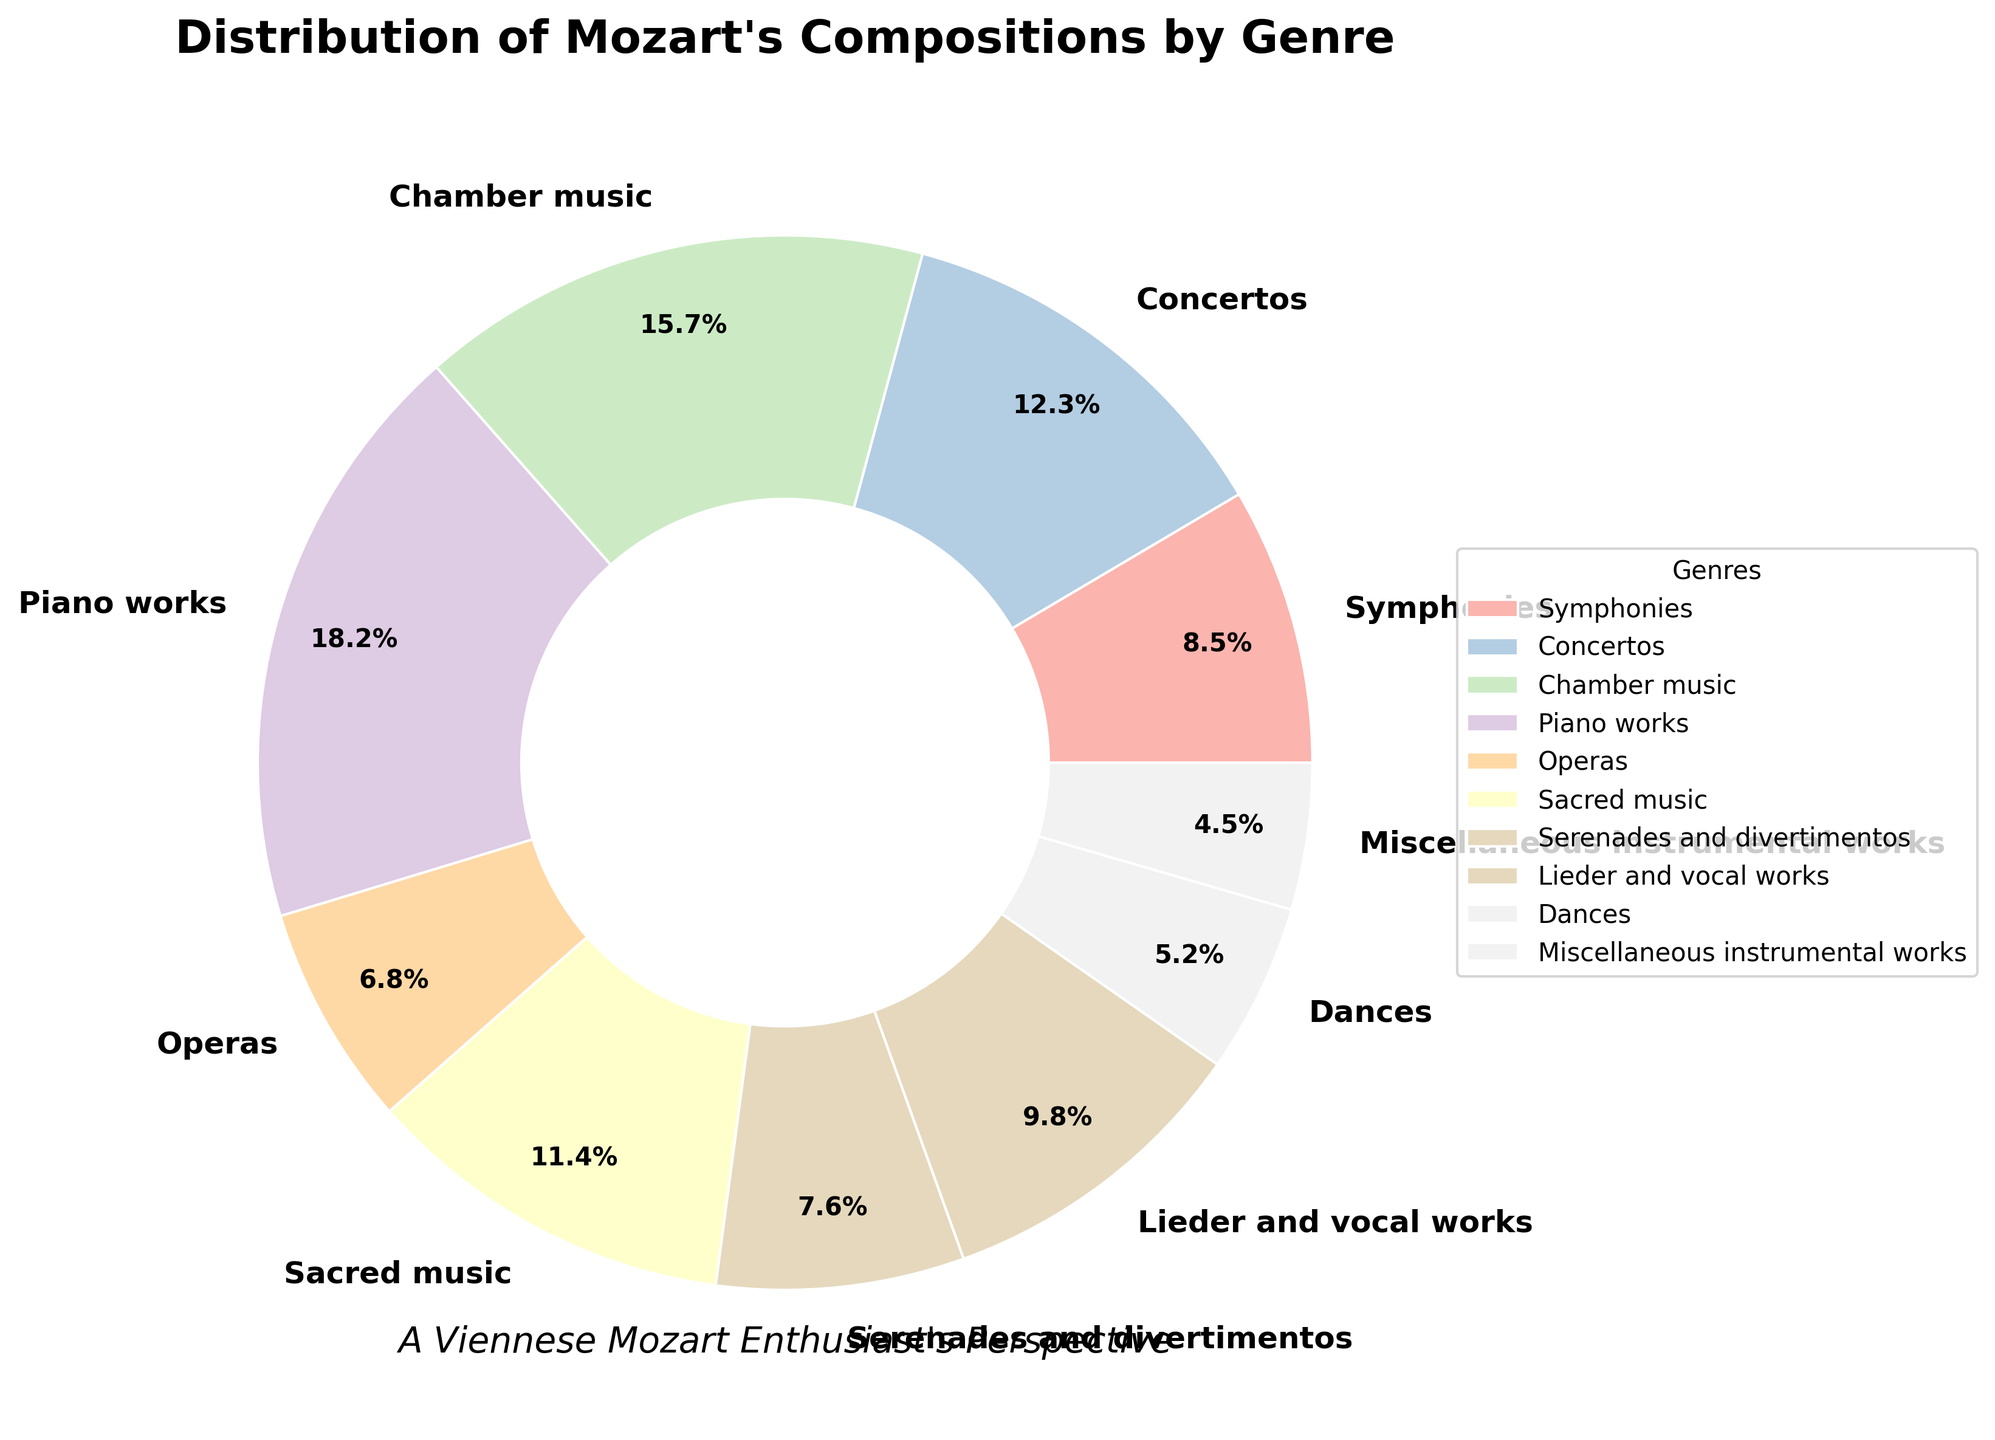what genre has the smallest percentage of Mozart's compositions? By looking at the pie chart, the segment labeled "Miscellaneous instrumental works" is the smallest.
Answer: Miscellaneous instrumental works Which genre has a higher percentage of Mozart's compositions: Operas or Lieder and vocal works? In the pie chart, the segment for Lieder and vocal works is labeled with 9.8% and the segment for Operas is labeled with 6.8%. Therefore, Lieder and vocal works have a higher percentage than Operas.
Answer: Lieder and vocal works What is the total percentage of Mozart's compositions in Piano works and Chamber music? From the pie chart, Piano works have a percentage of 18.2% and Chamber music has 15.7%. Adding these, 18.2 + 15.7 gives 33.9%.
Answer: 33.9% Which genre category closely approximates one-tenth of Mozart's compositions? The pie chart shows Sacred music at 11.4%, which is closest to one-tenth or 10%.
Answer: Sacred music Removing Sacred music and Concertos, what is the new total percentage of the remaining genres? Sacred music is 11.4% and Concertos is 12.3%. Removing these from 100%, 100% - 11.4% - 12.3% gives 76.3%.
Answer: 76.3% Which genre has more compositions: Serenades and divertimentos or Symphonies? According to the pie chart, Symphonies are labeled with 8.5% and Serenades and divertimentos are labeled with 7.6%. Thus, Symphonies have more compositions than Serenades and divertimentos.
Answer: Symphonies Looking at the colors, is the segment for Concertos distinctively different from Sacred music? The pie chart uses Pastel1 color map; each segment is distinctly colored. The segment for Concertos and Sacred music have different shades, ensuring visual distinction.
Answer: Yes Which three genres together make up more than 40% of Mozart's compositions? From the pie chart, the top three largest segments are Piano works (18.2%), Chamber music (15.7%), and Concertos (12.3%). Summing these gives 18.2 + 15.7 + 12.3, resulting in 46.2%, which is more than 40%.
Answer: Piano works, Chamber music, Concertos What combination of any two genres sums up to the largest percentage of Mozart's compositions? Looking at the largest segments, Piano works (18.2%) and Chamber music (15.7%). Summing these equals 33.9%, which is the highest combination compared to any other pair.
Answer: Piano works and Chamber music 